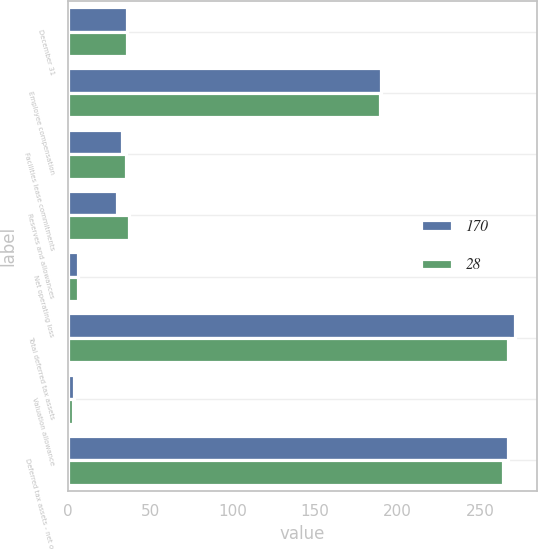Convert chart to OTSL. <chart><loc_0><loc_0><loc_500><loc_500><stacked_bar_chart><ecel><fcel>December 31<fcel>Employee compensation<fcel>Facilities lease commitments<fcel>Reserves and allowances<fcel>Net operating loss<fcel>Total deferred tax assets<fcel>Valuation allowance<fcel>Deferred tax assets - net of<nl><fcel>170<fcel>36<fcel>190<fcel>33<fcel>30<fcel>6<fcel>271<fcel>4<fcel>267<nl><fcel>28<fcel>36<fcel>189<fcel>35<fcel>37<fcel>6<fcel>267<fcel>3<fcel>264<nl></chart> 